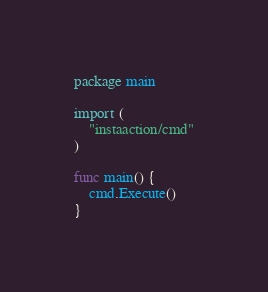Convert code to text. <code><loc_0><loc_0><loc_500><loc_500><_Go_>package main

import (
	"instaaction/cmd"
)

func main() {
	cmd.Execute()
}
</code> 